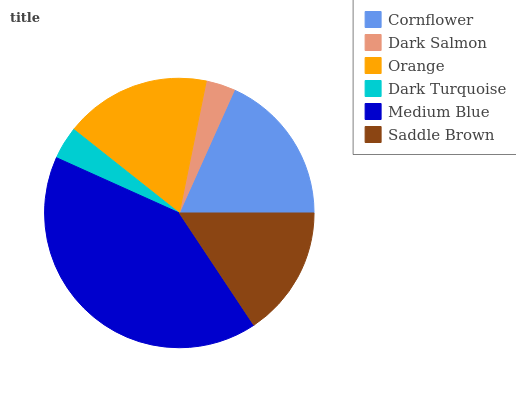Is Dark Salmon the minimum?
Answer yes or no. Yes. Is Medium Blue the maximum?
Answer yes or no. Yes. Is Orange the minimum?
Answer yes or no. No. Is Orange the maximum?
Answer yes or no. No. Is Orange greater than Dark Salmon?
Answer yes or no. Yes. Is Dark Salmon less than Orange?
Answer yes or no. Yes. Is Dark Salmon greater than Orange?
Answer yes or no. No. Is Orange less than Dark Salmon?
Answer yes or no. No. Is Orange the high median?
Answer yes or no. Yes. Is Saddle Brown the low median?
Answer yes or no. Yes. Is Saddle Brown the high median?
Answer yes or no. No. Is Orange the low median?
Answer yes or no. No. 